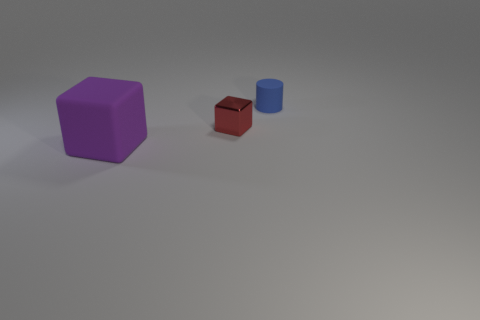Add 3 metal cubes. How many objects exist? 6 Subtract all cubes. How many objects are left? 1 Add 2 large purple rubber objects. How many large purple rubber objects are left? 3 Add 1 tiny red metallic things. How many tiny red metallic things exist? 2 Subtract 1 purple cubes. How many objects are left? 2 Subtract all red metal objects. Subtract all small red objects. How many objects are left? 1 